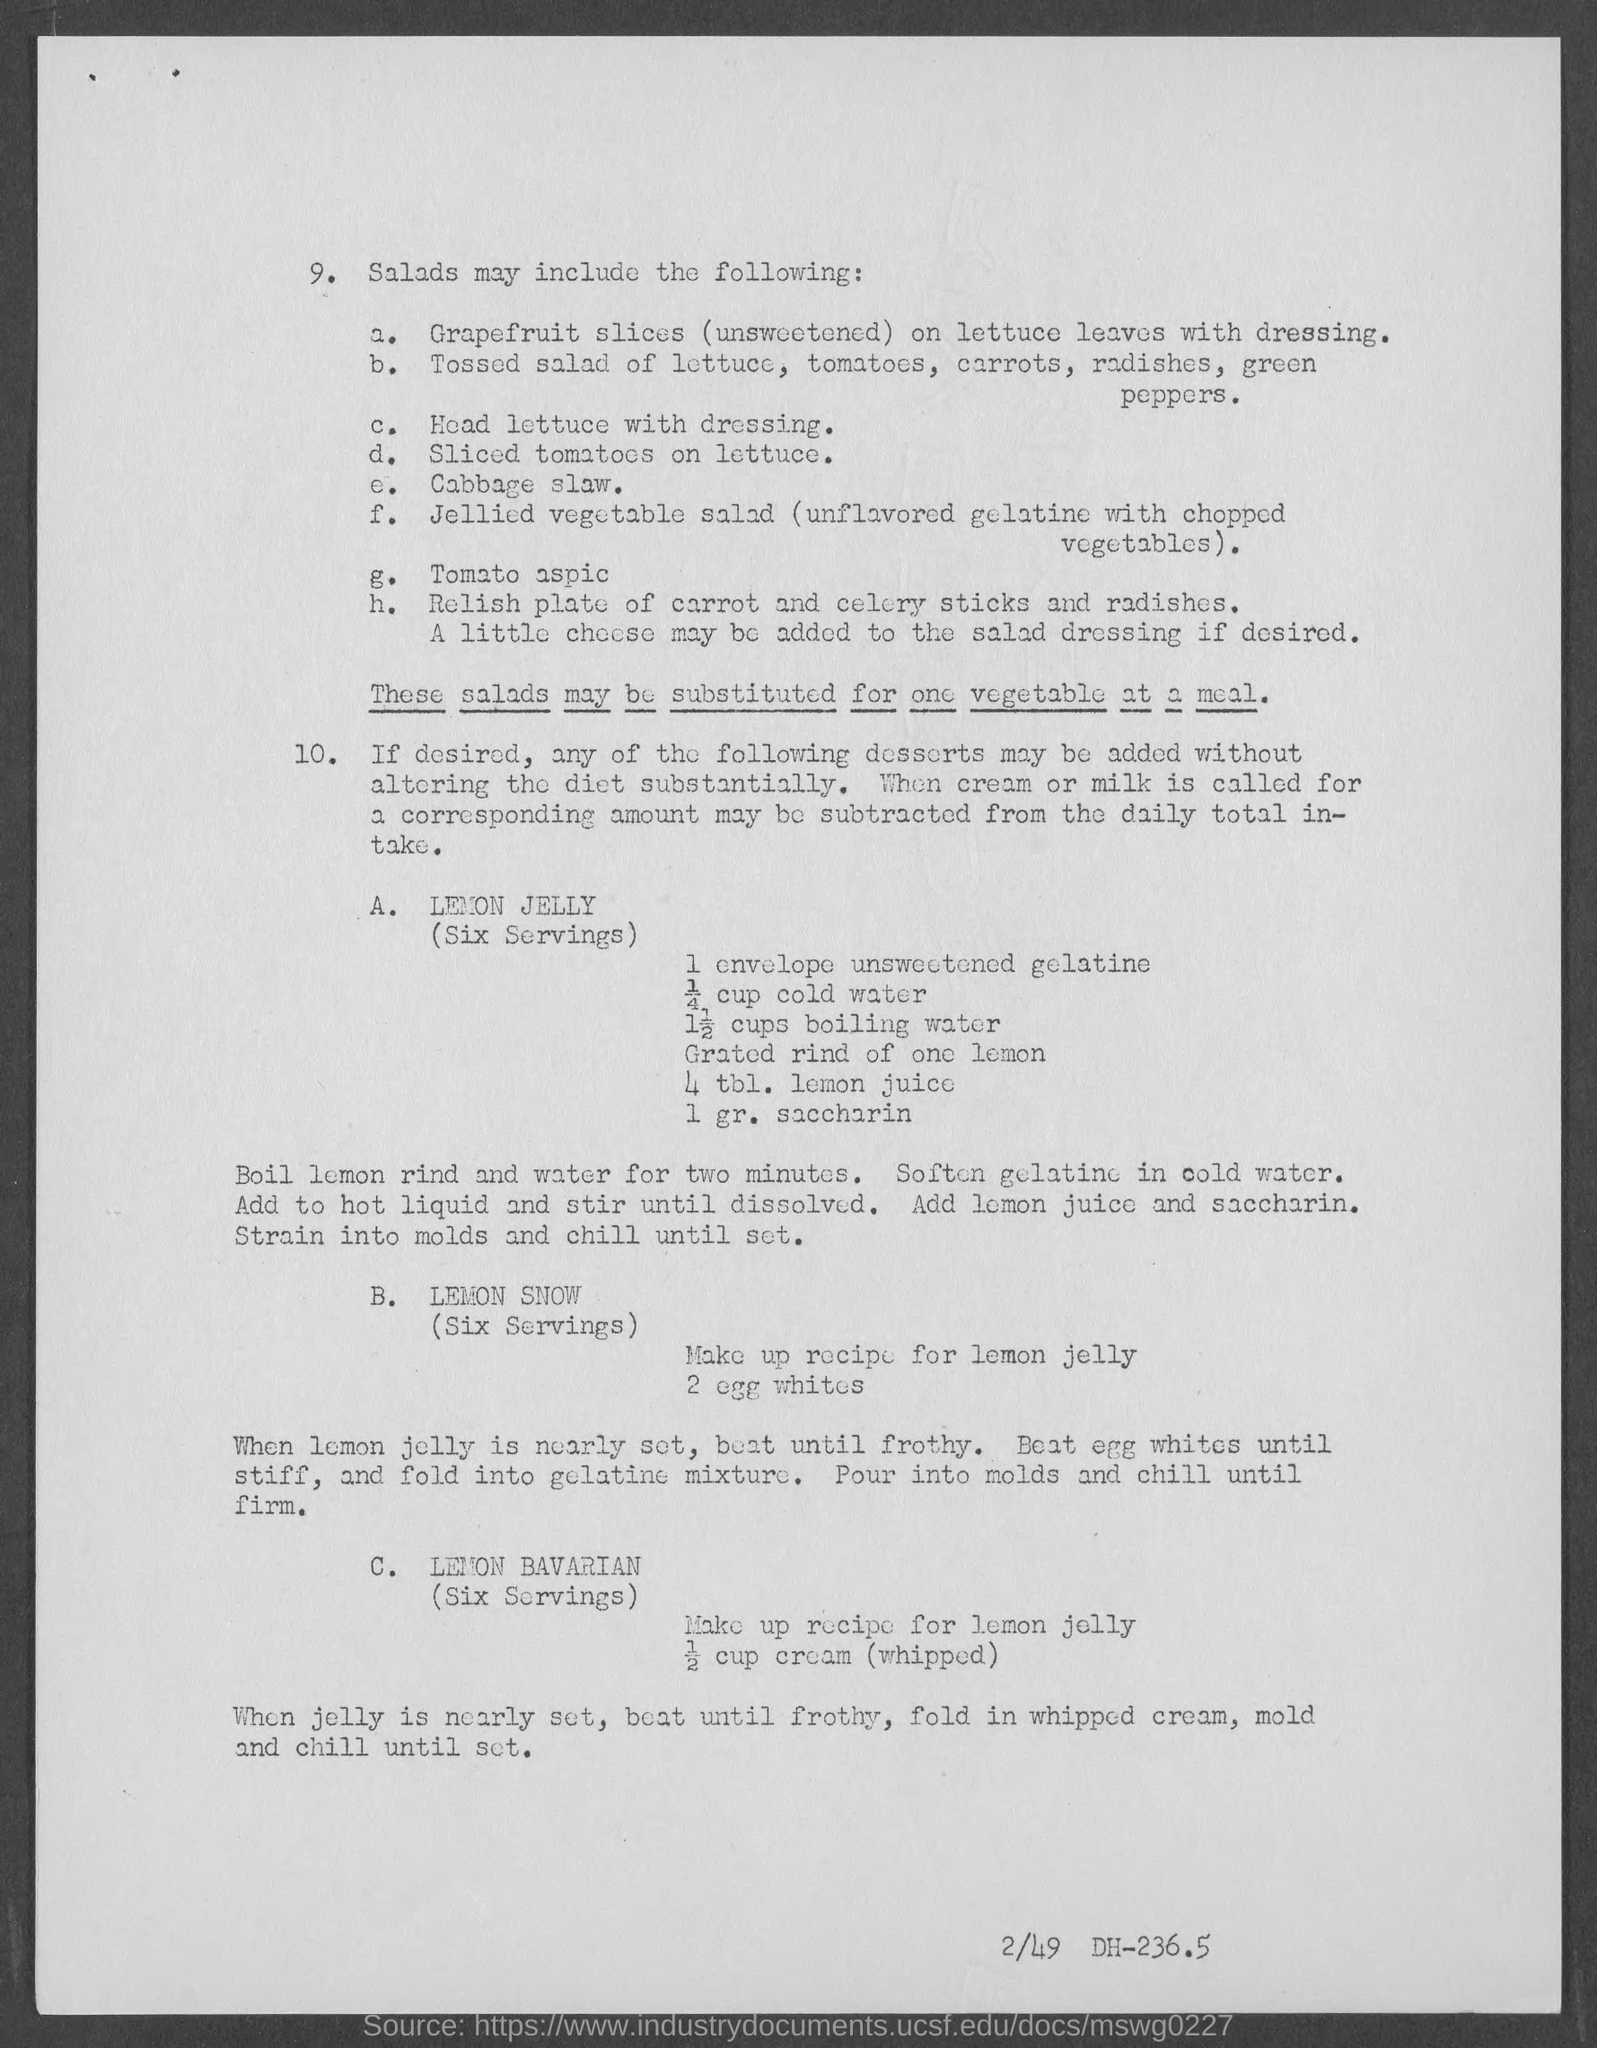Mention item "c" which may be included in making salads?
Your response must be concise. Head lettuce with dressing. Mention item "e" which may be included in making salads?
Make the answer very short. Cabbage slaw. Mention item "d" which may be included in making salads?
Provide a short and direct response. Sliced tomatoes on lettuce. Mention item "g" which may be included in making salads?
Provide a succinct answer. Tomato aspic. "These salads must be substituted for" what "at a meal"?
Your answer should be very brief. One  vegetable. Which dessert name is given  as "A" under "10"?
Offer a terse response. Lemon jelly. Which dessert name is given as "B" under "10"?
Your response must be concise. LEMON SNOW. Provide the reference number given at right bottom corner of the page?
Your answer should be compact. 2/49 DH-236.5. Dessert  recipe for how many servings is given?
Ensure brevity in your answer.  SIX SERVINGS. 